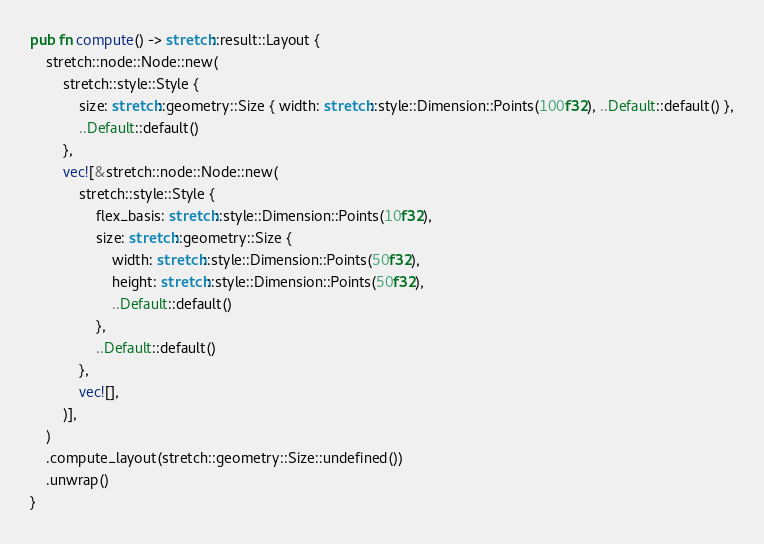Convert code to text. <code><loc_0><loc_0><loc_500><loc_500><_Rust_>pub fn compute() -> stretch::result::Layout {
    stretch::node::Node::new(
        stretch::style::Style {
            size: stretch::geometry::Size { width: stretch::style::Dimension::Points(100f32), ..Default::default() },
            ..Default::default()
        },
        vec![&stretch::node::Node::new(
            stretch::style::Style {
                flex_basis: stretch::style::Dimension::Points(10f32),
                size: stretch::geometry::Size {
                    width: stretch::style::Dimension::Points(50f32),
                    height: stretch::style::Dimension::Points(50f32),
                    ..Default::default()
                },
                ..Default::default()
            },
            vec![],
        )],
    )
    .compute_layout(stretch::geometry::Size::undefined())
    .unwrap()
}
</code> 